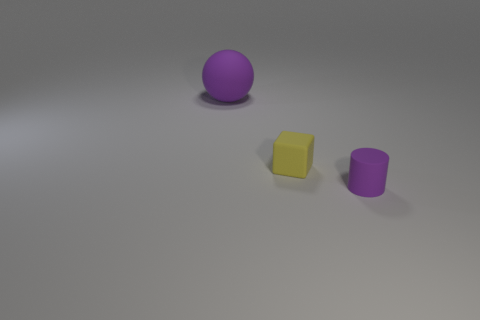Is there anything else that is the same size as the purple rubber ball?
Provide a short and direct response. No. Does the purple rubber sphere have the same size as the yellow thing?
Provide a short and direct response. No. The purple sphere is what size?
Provide a short and direct response. Large. What shape is the object that is the same color as the large ball?
Offer a terse response. Cylinder. Are there more small blue rubber blocks than small cylinders?
Your answer should be compact. No. There is a small object behind the rubber cylinder that is right of the small rubber thing behind the tiny purple rubber cylinder; what is its color?
Offer a very short reply. Yellow. Do the purple matte object that is in front of the purple sphere and the large object have the same shape?
Your answer should be compact. No. There is a matte object that is the same size as the yellow cube; what is its color?
Ensure brevity in your answer.  Purple. How many large purple rubber spheres are there?
Keep it short and to the point. 1. Is the thing that is behind the yellow thing made of the same material as the yellow block?
Your answer should be compact. Yes. 